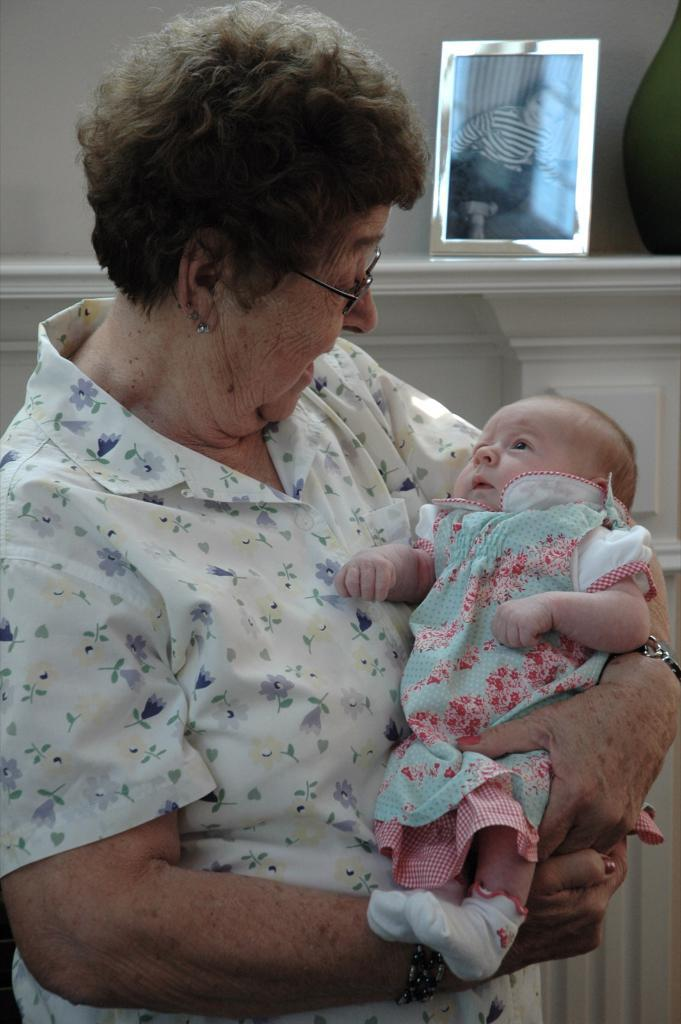Who is the main subject in the image? There is a woman in the image. What is the woman doing in the image? The woman is holding a baby. What can be seen in the background of the image? There is a wall in the background of the image. Can you describe any objects on the wall? There is a photo frame on the wall. What is the woman thinking about in the image? The image does not provide any information about the woman's thoughts, so we cannot determine what she is thinking about. 